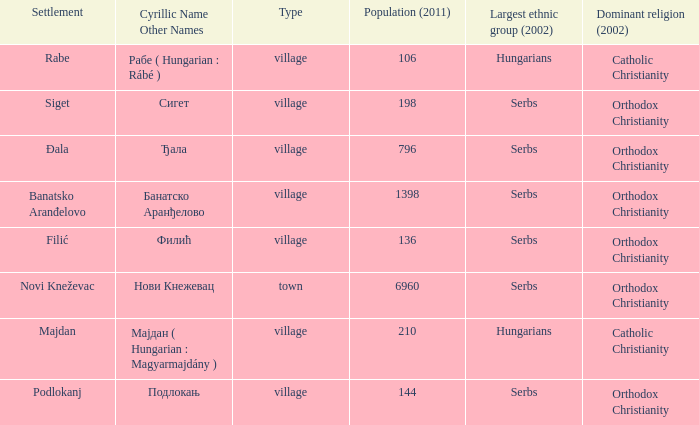Which settlement has the cyrillic name сигет?  Siget. 